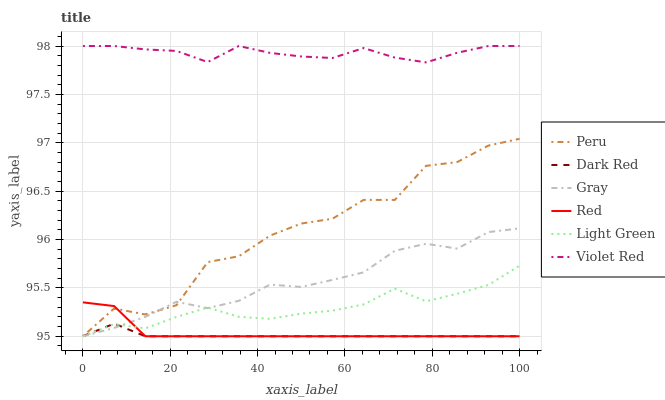Does Peru have the minimum area under the curve?
Answer yes or no. No. Does Peru have the maximum area under the curve?
Answer yes or no. No. Is Violet Red the smoothest?
Answer yes or no. No. Is Violet Red the roughest?
Answer yes or no. No. Does Violet Red have the lowest value?
Answer yes or no. No. Does Peru have the highest value?
Answer yes or no. No. Is Dark Red less than Violet Red?
Answer yes or no. Yes. Is Violet Red greater than Light Green?
Answer yes or no. Yes. Does Dark Red intersect Violet Red?
Answer yes or no. No. 